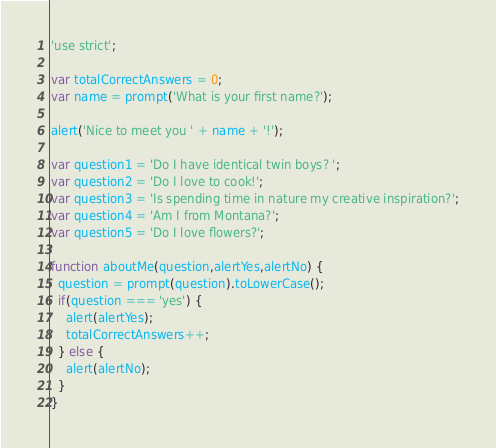<code> <loc_0><loc_0><loc_500><loc_500><_JavaScript_>'use strict';

var totalCorrectAnswers = 0;
var name = prompt('What is your first name?');

alert('Nice to meet you ' + name + '!');

var question1 = 'Do I have identical twin boys? ';
var question2 = 'Do I love to cook!';
var question3 = 'Is spending time in nature my creative inspiration?';
var question4 = 'Am I from Montana?';
var question5 = 'Do I love flowers?';

function aboutMe(question,alertYes,alertNo) {
  question = prompt(question).toLowerCase();
  if(question === 'yes') {
    alert(alertYes);
    totalCorrectAnswers++;
  } else {
    alert(alertNo);
  }
}
</code> 